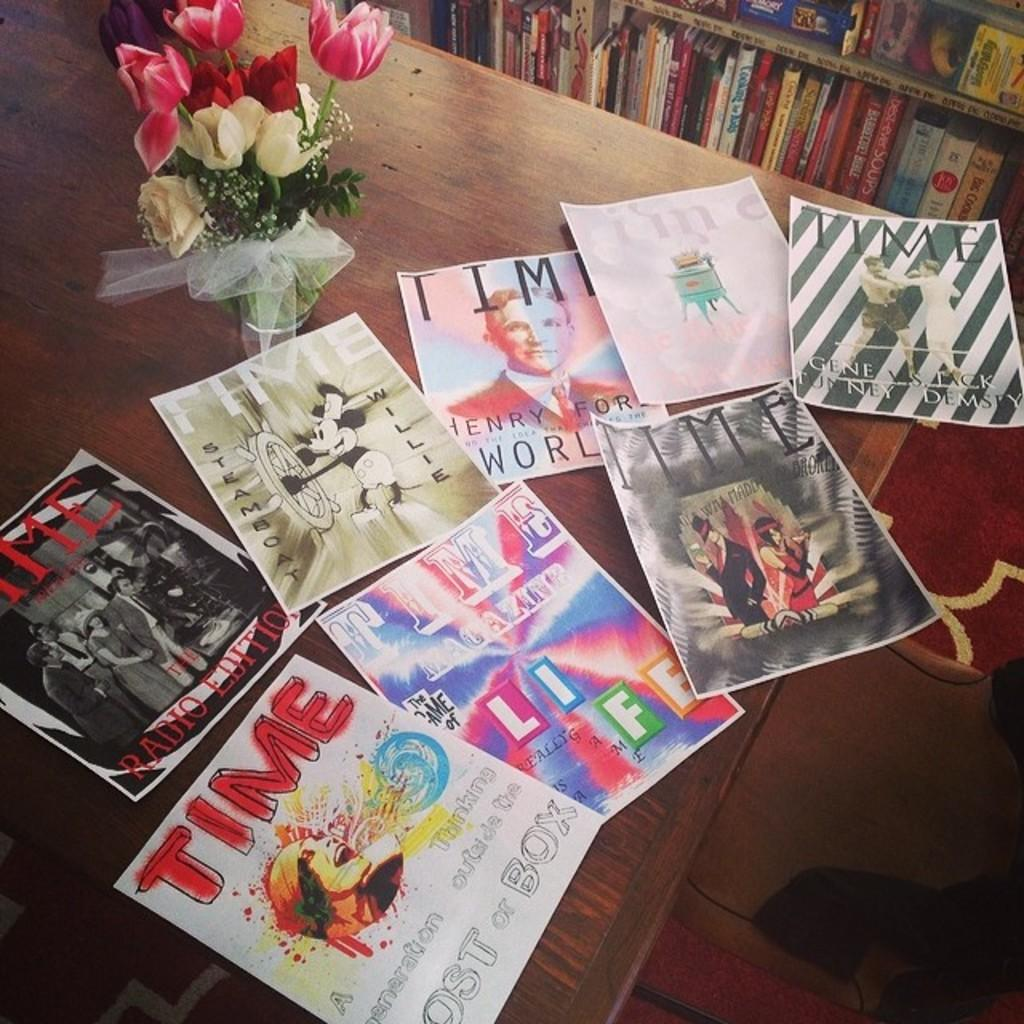<image>
Render a clear and concise summary of the photo. Various Time magazine covers are seen on a table. 